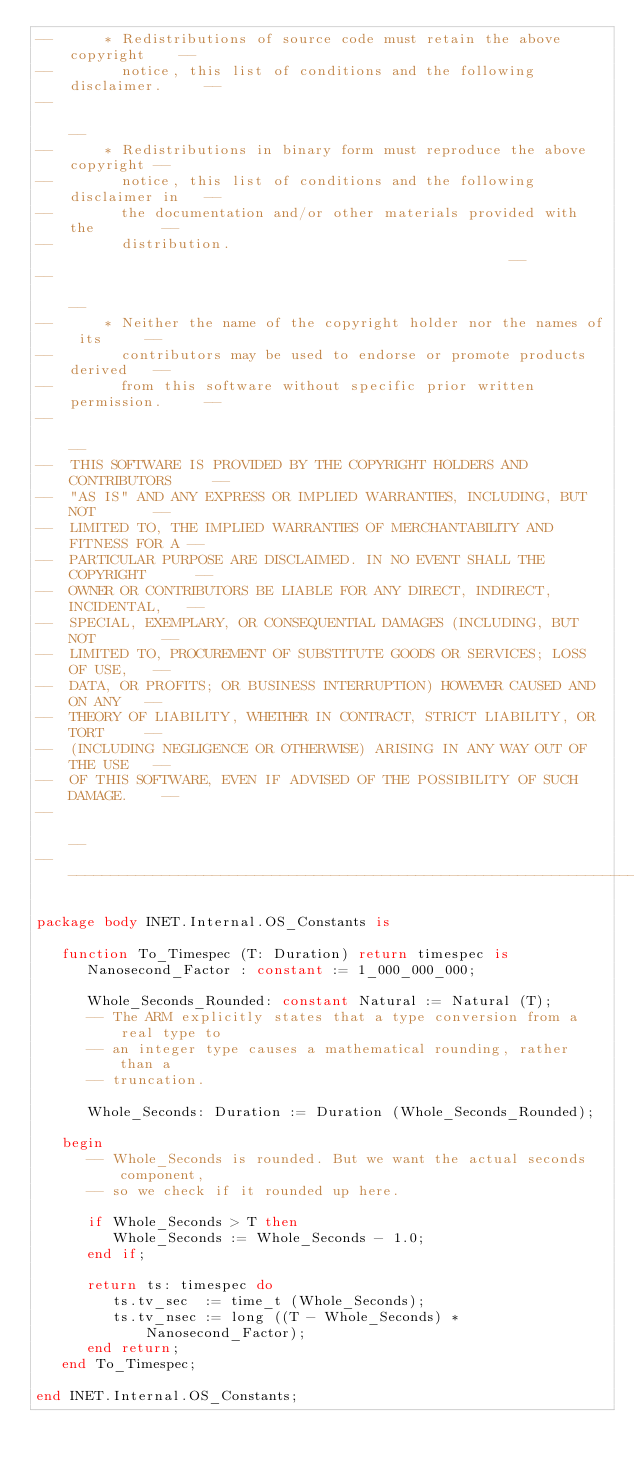Convert code to text. <code><loc_0><loc_0><loc_500><loc_500><_Ada_>--      * Redistributions of source code must retain the above copyright    --
--        notice, this list of conditions and the following disclaimer.     --
--                                                                          --
--      * Redistributions in binary form must reproduce the above copyright --
--        notice, this list of conditions and the following disclaimer in   --
--        the documentation and/or other materials provided with the        --
--        distribution.                                                     --
--                                                                          --
--      * Neither the name of the copyright holder nor the names of its     --
--        contributors may be used to endorse or promote products derived   --
--        from this software without specific prior written permission.     --
--                                                                          --
--  THIS SOFTWARE IS PROVIDED BY THE COPYRIGHT HOLDERS AND CONTRIBUTORS     --
--  "AS IS" AND ANY EXPRESS OR IMPLIED WARRANTIES, INCLUDING, BUT NOT       --
--  LIMITED TO, THE IMPLIED WARRANTIES OF MERCHANTABILITY AND FITNESS FOR A --
--  PARTICULAR PURPOSE ARE DISCLAIMED. IN NO EVENT SHALL THE COPYRIGHT      --
--  OWNER OR CONTRIBUTORS BE LIABLE FOR ANY DIRECT, INDIRECT, INCIDENTAL,   --
--  SPECIAL, EXEMPLARY, OR CONSEQUENTIAL DAMAGES (INCLUDING, BUT NOT        --
--  LIMITED TO, PROCUREMENT OF SUBSTITUTE GOODS OR SERVICES; LOSS OF USE,   --
--  DATA, OR PROFITS; OR BUSINESS INTERRUPTION) HOWEVER CAUSED AND ON ANY   --
--  THEORY OF LIABILITY, WHETHER IN CONTRACT, STRICT LIABILITY, OR TORT     --
--  (INCLUDING NEGLIGENCE OR OTHERWISE) ARISING IN ANY WAY OUT OF THE USE   --
--  OF THIS SOFTWARE, EVEN IF ADVISED OF THE POSSIBILITY OF SUCH DAMAGE.    --
--                                                                          --
------------------------------------------------------------------------------

package body INET.Internal.OS_Constants is
   
   function To_Timespec (T: Duration) return timespec is
      Nanosecond_Factor : constant := 1_000_000_000;
      
      Whole_Seconds_Rounded: constant Natural := Natural (T);
      -- The ARM explicitly states that a type conversion from a real type to
      -- an integer type causes a mathematical rounding, rather than a
      -- truncation.
      
      Whole_Seconds: Duration := Duration (Whole_Seconds_Rounded);
      
   begin
      -- Whole_Seconds is rounded. But we want the actual seconds component,
      -- so we check if it rounded up here.
      
      if Whole_Seconds > T then
         Whole_Seconds := Whole_Seconds - 1.0;
      end if;
      
      return ts: timespec do
         ts.tv_sec  := time_t (Whole_Seconds);
         ts.tv_nsec := long ((T - Whole_Seconds) * Nanosecond_Factor);
      end return;   
   end To_Timespec;
   
end INET.Internal.OS_Constants;
</code> 